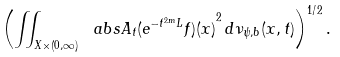Convert formula to latex. <formula><loc_0><loc_0><loc_500><loc_500>\left ( \iint _ { X \times ( 0 , \infty ) } \ a b s { A _ { t } ( e ^ { - t ^ { 2 m } L } f ) ( x ) } ^ { 2 } \, d \nu _ { \psi , b } ( x , t ) \right ) ^ { 1 / 2 } .</formula> 